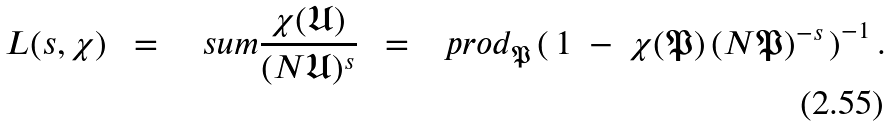<formula> <loc_0><loc_0><loc_500><loc_500>L ( s , \chi ) \ \ = \quad s u m { \frac { \chi ( \mathfrak { U } ) } { ( N \mathfrak { U } ) ^ { s } } } \ \ = \ \ \ p r o d _ { \mathfrak { P } } \left ( \, 1 \ - \ { \chi } ( \mathfrak { P } ) \, ( N { \mathfrak { P } } ) ^ { - s } \, \right ) ^ { - 1 } .</formula> 